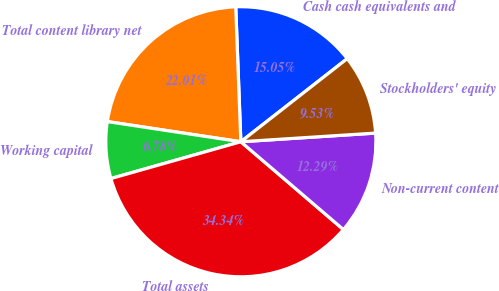Convert chart to OTSL. <chart><loc_0><loc_0><loc_500><loc_500><pie_chart><fcel>Cash cash equivalents and<fcel>Total content library net<fcel>Working capital<fcel>Total assets<fcel>Non-current content<fcel>Stockholders' equity<nl><fcel>15.05%<fcel>22.01%<fcel>6.78%<fcel>34.34%<fcel>12.29%<fcel>9.53%<nl></chart> 